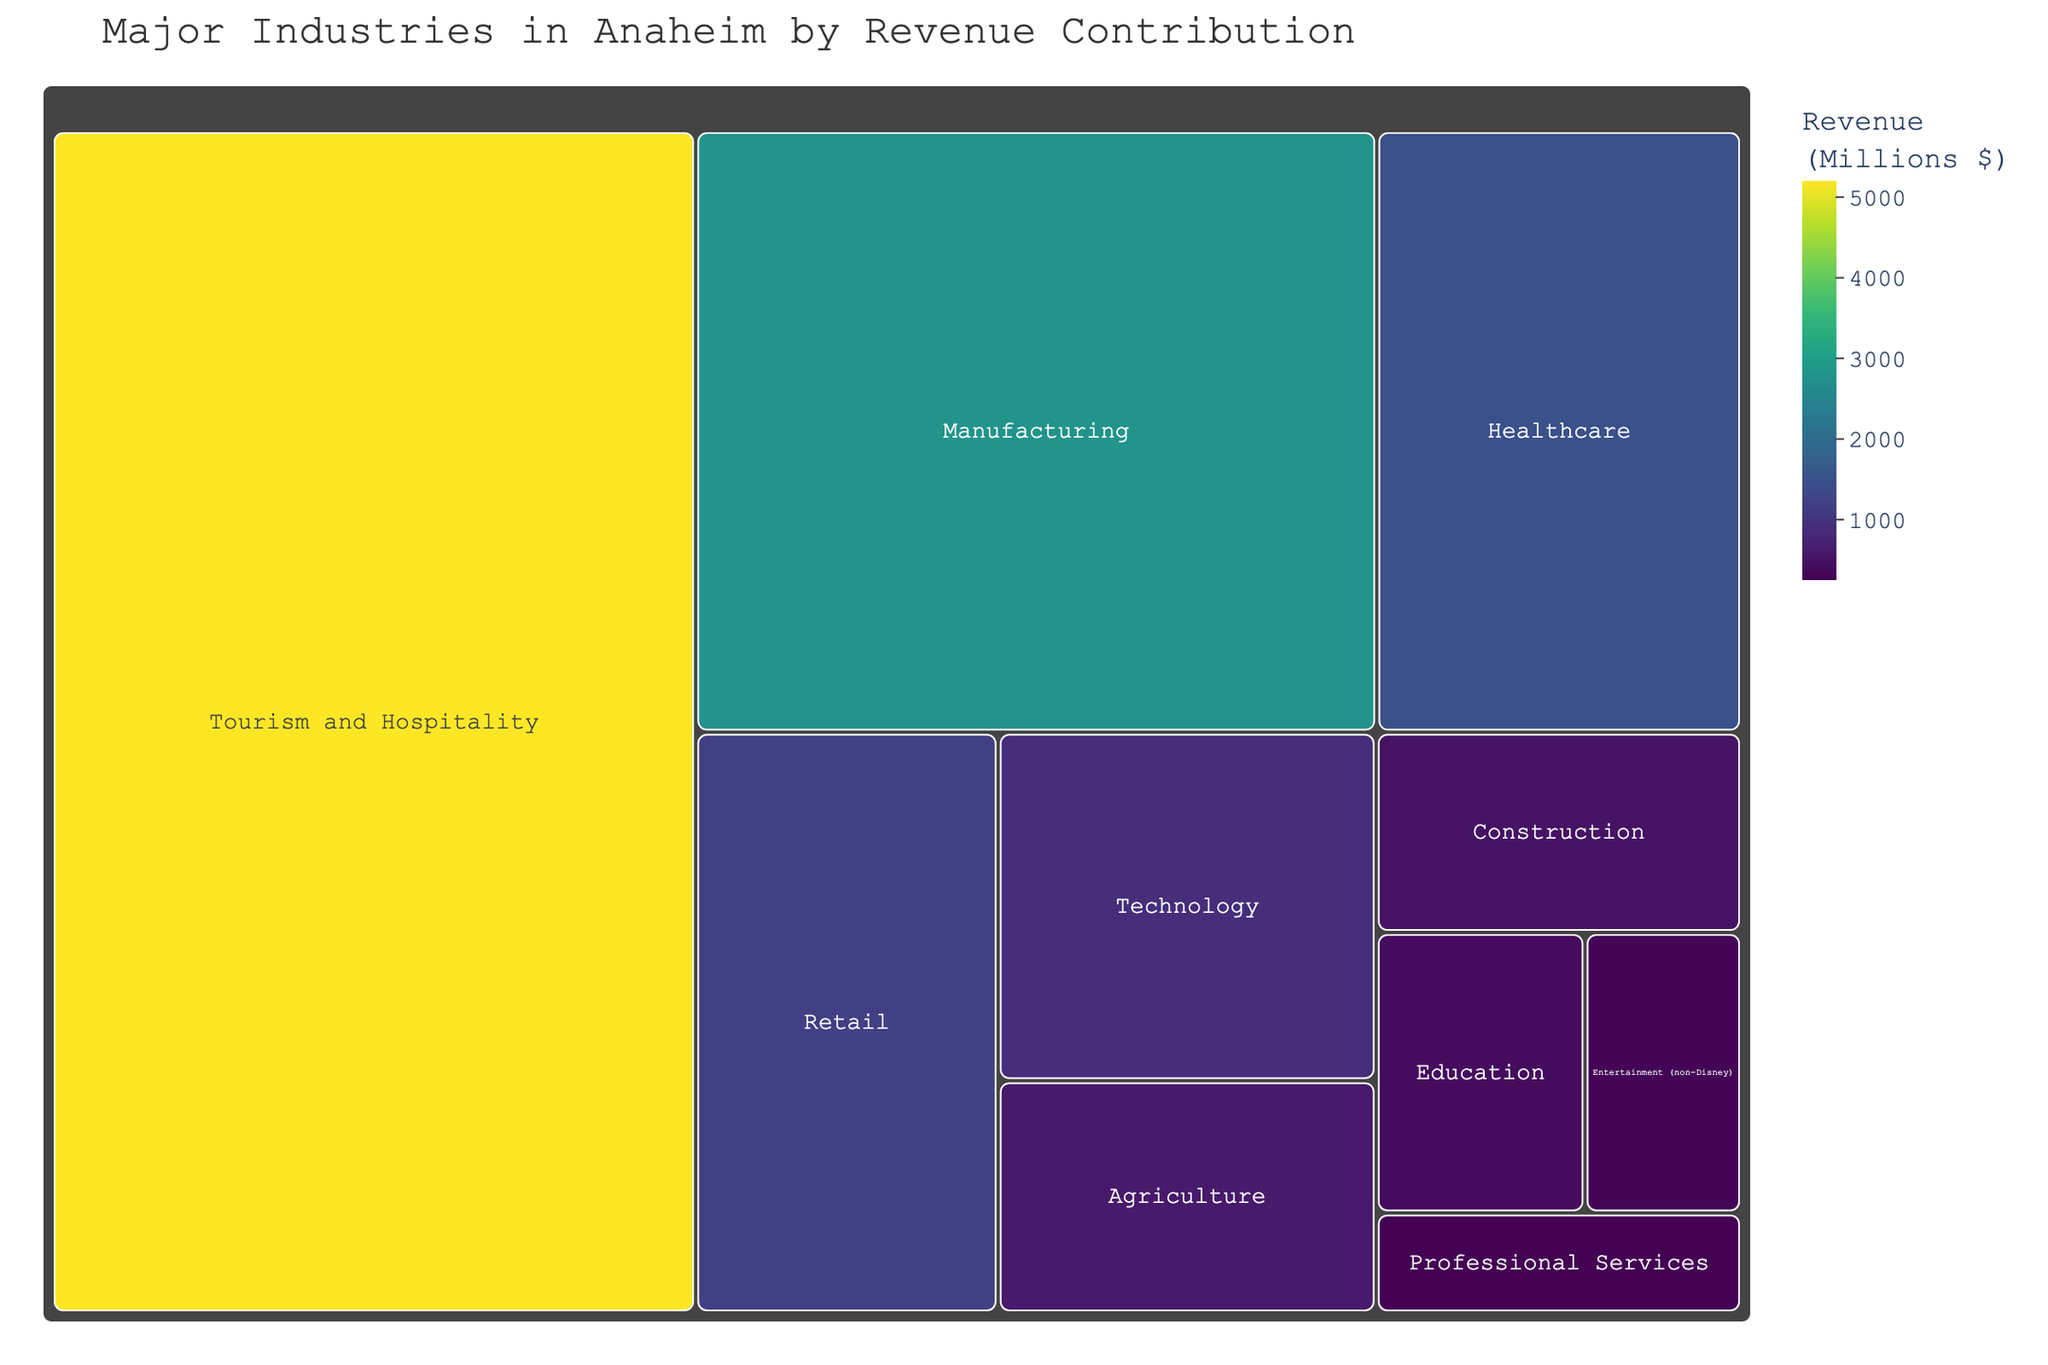What's the largest industry in Anaheim by revenue contribution? The treemap visually sizes each industry proportionally based on revenue contribution, with the largest area representing the highest revenue.
Answer: Tourism and Hospitality How much more revenue does Tourism and Hospitality generate compared to Manufacturing? Tourism and Hospitality generates $5,200 million in revenue, while Manufacturing generates $2,800 million. The difference is $5,200 million - $2,800 million.
Answer: $2,400 million Which two industries combined have a revenue contribution similar to Manufacturing? Manufacturing has a revenue contribution of $2,800 million. Adding the revenue of Healthcare ($1,500 million) and Retail ($1,200 million) gives $2,700 million, which is close to $2,800 million.
Answer: Healthcare and Retail combined Order the industries from highest to lowest revenue contribution. The treemap visually orders industries by revenue, starting with the largest: (1) Tourism and Hospitality, (2) Manufacturing, (3) Healthcare, (4) Retail, (5) Technology, (6) Agriculture, (7) Construction, (8) Education, (9) Entertainment (non-Disney), and (10) Professional Services.
Answer: Tourism and Hospitality, Manufacturing, Healthcare, Retail, Technology, Agriculture, Construction, Education, Entertainment (non-Disney), Professional Services What is the total revenue contribution of all industries combined in Anaheim? Summing up all listed revenues: $5,200M + $2,800M + $1,500M + $1,200M + $900M + $600M + $500M + $400M + $300M + $250M = $13,650 million.
Answer: $13,650 million Which industry has the smallest contribution, and what is its contribution? The smallest area in the treemap corresponds to Professional Services.
Answer: Professional Services, $250 million How does the revenue of Technology compare to that of Agriculture and Construction combined? Technology has a revenue of $900 million. Agriculture and Construction combined have $600 million + $500 million = $1,100 million.
Answer: $200 million less What percentage of total revenue contribution does Healthcare represent? Healthcare contributes $1,500M out of the total $13,650M. The percentage is ($1,500M / $13,650M) * 100%.
Answer: Approximately 11% Which industries have a revenue contribution between $500 million and $1,000 million? The treemap indicates Technology ($900M), Agriculture ($600M), and Construction ($500M) fall in this range.
Answer: Technology, Agriculture, and Construction How significant is the contribution of Entertainment (non-Disney) compared to Education? Both are visually represented in similar but distinct sections, with Entertainment (non-Disney) contributing $300M and Education contributing $400M. Entertainment (non-Disney) is $100M less than Education.
Answer: $100 million less 